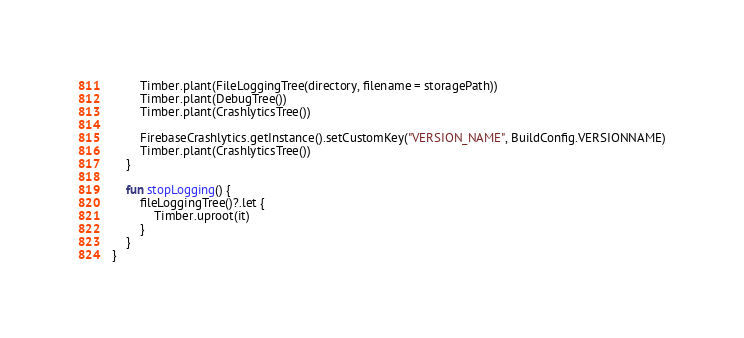<code> <loc_0><loc_0><loc_500><loc_500><_Kotlin_>        Timber.plant(FileLoggingTree(directory, filename = storagePath))
        Timber.plant(DebugTree())
        Timber.plant(CrashlyticsTree())

        FirebaseCrashlytics.getInstance().setCustomKey("VERSION_NAME", BuildConfig.VERSIONNAME)
        Timber.plant(CrashlyticsTree())
    }

    fun stopLogging() {
        fileLoggingTree()?.let {
            Timber.uproot(it)
        }
    }
}
</code> 